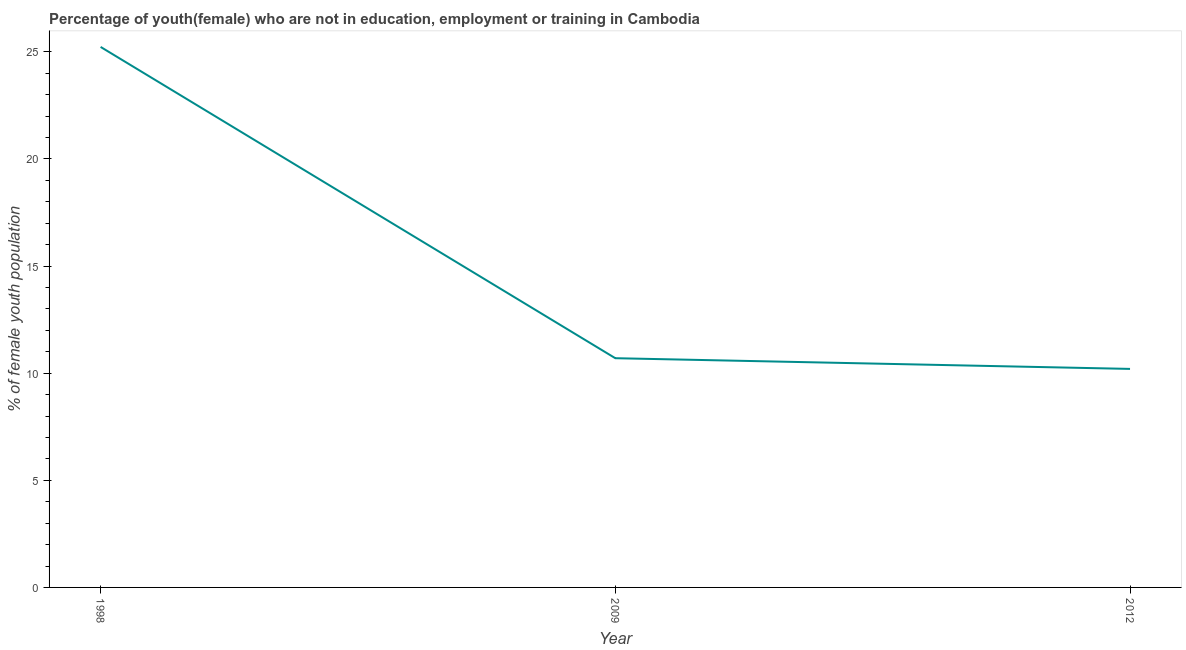What is the unemployed female youth population in 1998?
Provide a succinct answer. 25.23. Across all years, what is the maximum unemployed female youth population?
Provide a succinct answer. 25.23. Across all years, what is the minimum unemployed female youth population?
Your answer should be very brief. 10.2. What is the sum of the unemployed female youth population?
Your answer should be compact. 46.13. What is the difference between the unemployed female youth population in 1998 and 2012?
Offer a very short reply. 15.03. What is the average unemployed female youth population per year?
Offer a very short reply. 15.38. What is the median unemployed female youth population?
Keep it short and to the point. 10.7. Do a majority of the years between 2009 and 2012 (inclusive) have unemployed female youth population greater than 7 %?
Make the answer very short. Yes. What is the ratio of the unemployed female youth population in 1998 to that in 2012?
Provide a succinct answer. 2.47. Is the unemployed female youth population in 1998 less than that in 2012?
Ensure brevity in your answer.  No. What is the difference between the highest and the second highest unemployed female youth population?
Your answer should be compact. 14.53. Is the sum of the unemployed female youth population in 1998 and 2009 greater than the maximum unemployed female youth population across all years?
Your answer should be compact. Yes. What is the difference between the highest and the lowest unemployed female youth population?
Your answer should be compact. 15.03. How many lines are there?
Offer a terse response. 1. Are the values on the major ticks of Y-axis written in scientific E-notation?
Your answer should be very brief. No. What is the title of the graph?
Provide a succinct answer. Percentage of youth(female) who are not in education, employment or training in Cambodia. What is the label or title of the Y-axis?
Your answer should be very brief. % of female youth population. What is the % of female youth population in 1998?
Provide a succinct answer. 25.23. What is the % of female youth population of 2009?
Your response must be concise. 10.7. What is the % of female youth population in 2012?
Offer a very short reply. 10.2. What is the difference between the % of female youth population in 1998 and 2009?
Offer a terse response. 14.53. What is the difference between the % of female youth population in 1998 and 2012?
Provide a succinct answer. 15.03. What is the difference between the % of female youth population in 2009 and 2012?
Your response must be concise. 0.5. What is the ratio of the % of female youth population in 1998 to that in 2009?
Offer a terse response. 2.36. What is the ratio of the % of female youth population in 1998 to that in 2012?
Your answer should be compact. 2.47. What is the ratio of the % of female youth population in 2009 to that in 2012?
Make the answer very short. 1.05. 